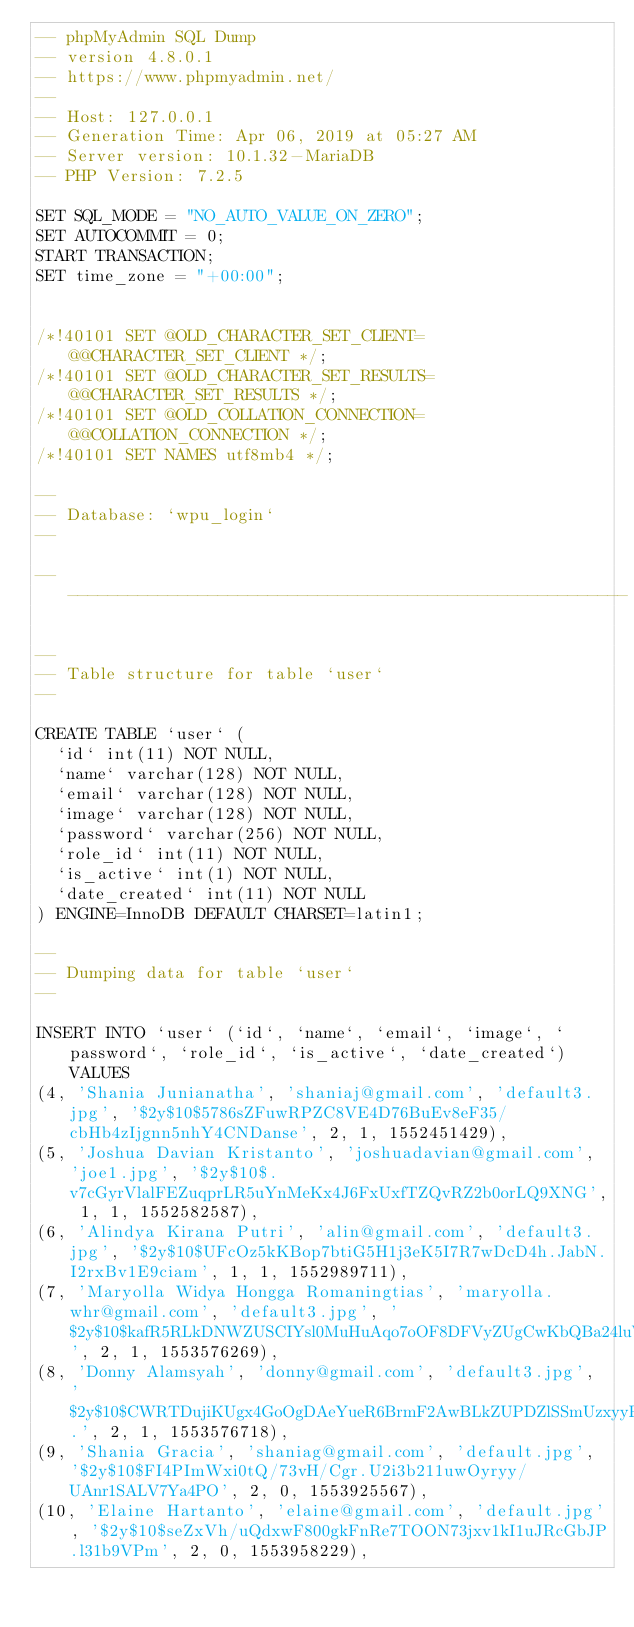<code> <loc_0><loc_0><loc_500><loc_500><_SQL_>-- phpMyAdmin SQL Dump
-- version 4.8.0.1
-- https://www.phpmyadmin.net/
--
-- Host: 127.0.0.1
-- Generation Time: Apr 06, 2019 at 05:27 AM
-- Server version: 10.1.32-MariaDB
-- PHP Version: 7.2.5

SET SQL_MODE = "NO_AUTO_VALUE_ON_ZERO";
SET AUTOCOMMIT = 0;
START TRANSACTION;
SET time_zone = "+00:00";


/*!40101 SET @OLD_CHARACTER_SET_CLIENT=@@CHARACTER_SET_CLIENT */;
/*!40101 SET @OLD_CHARACTER_SET_RESULTS=@@CHARACTER_SET_RESULTS */;
/*!40101 SET @OLD_COLLATION_CONNECTION=@@COLLATION_CONNECTION */;
/*!40101 SET NAMES utf8mb4 */;

--
-- Database: `wpu_login`
--

-- --------------------------------------------------------

--
-- Table structure for table `user`
--

CREATE TABLE `user` (
  `id` int(11) NOT NULL,
  `name` varchar(128) NOT NULL,
  `email` varchar(128) NOT NULL,
  `image` varchar(128) NOT NULL,
  `password` varchar(256) NOT NULL,
  `role_id` int(11) NOT NULL,
  `is_active` int(1) NOT NULL,
  `date_created` int(11) NOT NULL
) ENGINE=InnoDB DEFAULT CHARSET=latin1;

--
-- Dumping data for table `user`
--

INSERT INTO `user` (`id`, `name`, `email`, `image`, `password`, `role_id`, `is_active`, `date_created`) VALUES
(4, 'Shania Junianatha', 'shaniaj@gmail.com', 'default3.jpg', '$2y$10$5786sZFuwRPZC8VE4D76BuEv8eF35/cbHb4zIjgnn5nhY4CNDanse', 2, 1, 1552451429),
(5, 'Joshua Davian Kristanto', 'joshuadavian@gmail.com', 'joe1.jpg', '$2y$10$.v7cGyrVlalFEZuqprLR5uYnMeKx4J6FxUxfTZQvRZ2b0orLQ9XNG', 1, 1, 1552582587),
(6, 'Alindya Kirana Putri', 'alin@gmail.com', 'default3.jpg', '$2y$10$UFcOz5kKBop7btiG5H1j3eK5I7R7wDcD4h.JabN.I2rxBv1E9ciam', 1, 1, 1552989711),
(7, 'Maryolla Widya Hongga Romaningtias', 'maryolla.whr@gmail.com', 'default3.jpg', '$2y$10$kafR5RLkDNWZUSCIYsl0MuHuAqo7oOF8DFVyZUgCwKbQBa24luWpS', 2, 1, 1553576269),
(8, 'Donny Alamsyah', 'donny@gmail.com', 'default3.jpg', '$2y$10$CWRTDujiKUgx4GoOgDAeYueR6BrmF2AwBLkZUPDZlSSmUzxyyPp8.', 2, 1, 1553576718),
(9, 'Shania Gracia', 'shaniag@gmail.com', 'default.jpg', '$2y$10$FI4PImWxi0tQ/73vH/Cgr.U2i3b211uwOyryy/UAnr1SALV7Ya4PO', 2, 0, 1553925567),
(10, 'Elaine Hartanto', 'elaine@gmail.com', 'default.jpg', '$2y$10$seZxVh/uQdxwF800gkFnRe7TOON73jxv1kI1uJRcGbJP.l31b9VPm', 2, 0, 1553958229),</code> 